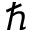<formula> <loc_0><loc_0><loc_500><loc_500>\hbar</formula> 